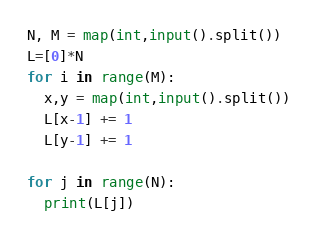Convert code to text. <code><loc_0><loc_0><loc_500><loc_500><_Python_>N, M = map(int,input().split())
L=[0]*N
for i in range(M):
  x,y = map(int,input().split())
  L[x-1] += 1
  L[y-1] += 1

for j in range(N):
  print(L[j])
</code> 